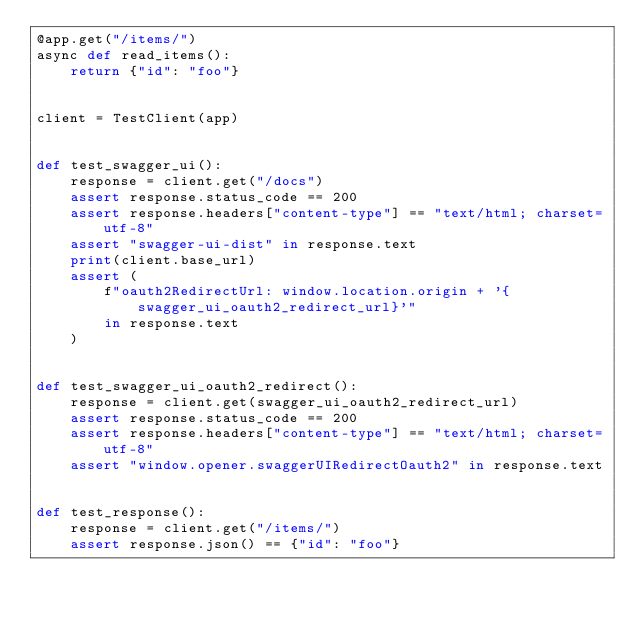Convert code to text. <code><loc_0><loc_0><loc_500><loc_500><_Python_>@app.get("/items/")
async def read_items():
    return {"id": "foo"}


client = TestClient(app)


def test_swagger_ui():
    response = client.get("/docs")
    assert response.status_code == 200
    assert response.headers["content-type"] == "text/html; charset=utf-8"
    assert "swagger-ui-dist" in response.text
    print(client.base_url)
    assert (
        f"oauth2RedirectUrl: window.location.origin + '{swagger_ui_oauth2_redirect_url}'"
        in response.text
    )


def test_swagger_ui_oauth2_redirect():
    response = client.get(swagger_ui_oauth2_redirect_url)
    assert response.status_code == 200
    assert response.headers["content-type"] == "text/html; charset=utf-8"
    assert "window.opener.swaggerUIRedirectOauth2" in response.text


def test_response():
    response = client.get("/items/")
    assert response.json() == {"id": "foo"}
</code> 